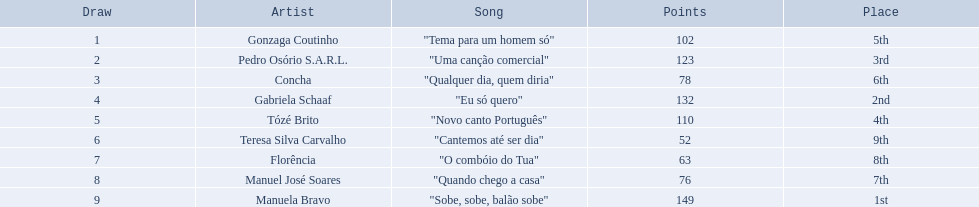Which song finished as the second best in the competition? "Eu só quero". Can you parse all the data within this table? {'header': ['Draw', 'Artist', 'Song', 'Points', 'Place'], 'rows': [['1', 'Gonzaga Coutinho', '"Tema para um homem só"', '102', '5th'], ['2', 'Pedro Osório S.A.R.L.', '"Uma canção comercial"', '123', '3rd'], ['3', 'Concha', '"Qualquer dia, quem diria"', '78', '6th'], ['4', 'Gabriela Schaaf', '"Eu só quero"', '132', '2nd'], ['5', 'Tózé Brito', '"Novo canto Português"', '110', '4th'], ['6', 'Teresa Silva Carvalho', '"Cantemos até ser dia"', '52', '9th'], ['7', 'Florência', '"O combóio do Tua"', '63', '8th'], ['8', 'Manuel José Soares', '"Quando chego a casa"', '76', '7th'], ['9', 'Manuela Bravo', '"Sobe, sobe, balão sobe"', '149', '1st']]} Who was the singer of "eu so quero"? Gabriela Schaaf. 